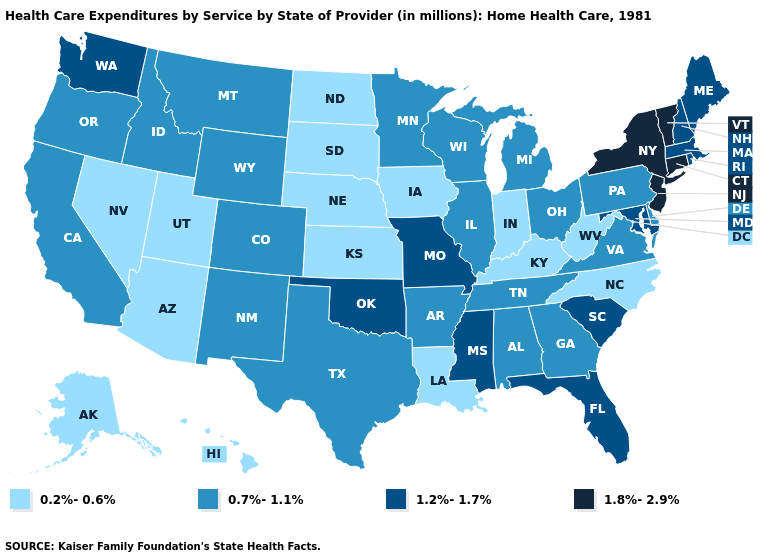Name the states that have a value in the range 0.2%-0.6%?
Give a very brief answer. Alaska, Arizona, Hawaii, Indiana, Iowa, Kansas, Kentucky, Louisiana, Nebraska, Nevada, North Carolina, North Dakota, South Dakota, Utah, West Virginia. What is the lowest value in the West?
Keep it brief. 0.2%-0.6%. What is the lowest value in the MidWest?
Concise answer only. 0.2%-0.6%. What is the lowest value in the Northeast?
Write a very short answer. 0.7%-1.1%. Name the states that have a value in the range 0.7%-1.1%?
Concise answer only. Alabama, Arkansas, California, Colorado, Delaware, Georgia, Idaho, Illinois, Michigan, Minnesota, Montana, New Mexico, Ohio, Oregon, Pennsylvania, Tennessee, Texas, Virginia, Wisconsin, Wyoming. Does the map have missing data?
Be succinct. No. What is the value of Alabama?
Short answer required. 0.7%-1.1%. Does New York have the lowest value in the USA?
Keep it brief. No. Name the states that have a value in the range 1.8%-2.9%?
Answer briefly. Connecticut, New Jersey, New York, Vermont. Which states have the lowest value in the South?
Give a very brief answer. Kentucky, Louisiana, North Carolina, West Virginia. Does Illinois have a lower value than Washington?
Give a very brief answer. Yes. Among the states that border Iowa , which have the lowest value?
Give a very brief answer. Nebraska, South Dakota. What is the highest value in the West ?
Be succinct. 1.2%-1.7%. Does Kentucky have a higher value than Delaware?
Concise answer only. No. What is the value of Vermont?
Write a very short answer. 1.8%-2.9%. 